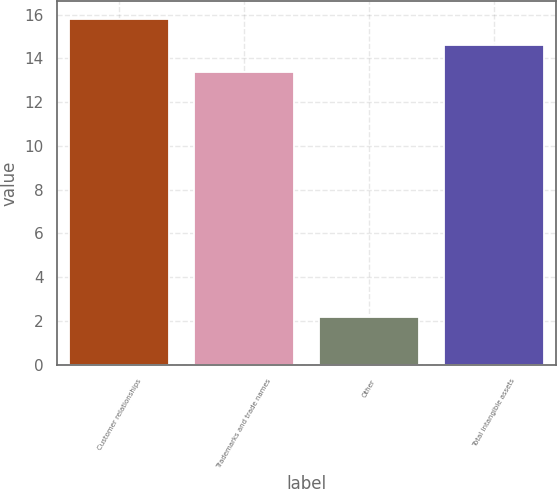<chart> <loc_0><loc_0><loc_500><loc_500><bar_chart><fcel>Customer relationships<fcel>Trademarks and trade names<fcel>Other<fcel>Total intangible assets<nl><fcel>15.82<fcel>13.4<fcel>2.2<fcel>14.61<nl></chart> 